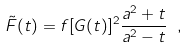<formula> <loc_0><loc_0><loc_500><loc_500>\tilde { F } ( t ) = f [ G ( t ) ] ^ { 2 } \frac { a ^ { 2 } + t } { a ^ { 2 } - t } \ ,</formula> 